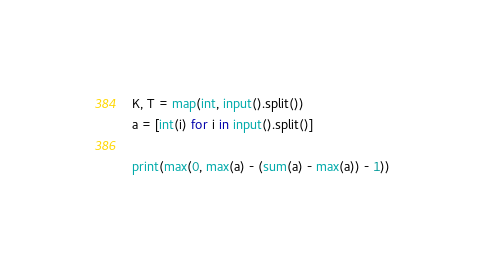Convert code to text. <code><loc_0><loc_0><loc_500><loc_500><_Python_>K, T = map(int, input().split())
a = [int(i) for i in input().split()]

print(max(0, max(a) - (sum(a) - max(a)) - 1))</code> 